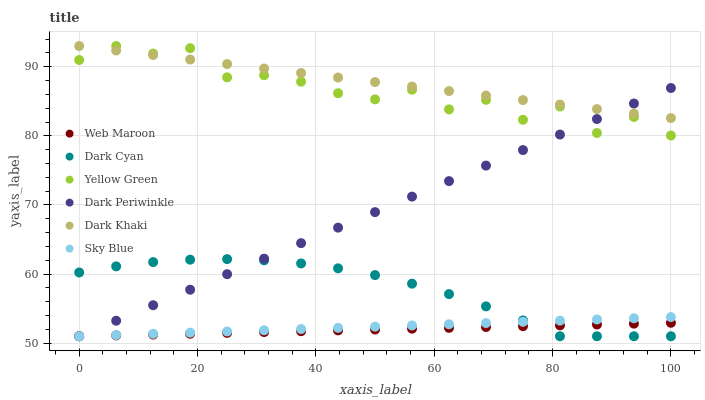Does Web Maroon have the minimum area under the curve?
Answer yes or no. Yes. Does Dark Khaki have the maximum area under the curve?
Answer yes or no. Yes. Does Dark Khaki have the minimum area under the curve?
Answer yes or no. No. Does Web Maroon have the maximum area under the curve?
Answer yes or no. No. Is Web Maroon the smoothest?
Answer yes or no. Yes. Is Yellow Green the roughest?
Answer yes or no. Yes. Is Dark Khaki the smoothest?
Answer yes or no. No. Is Dark Khaki the roughest?
Answer yes or no. No. Does Web Maroon have the lowest value?
Answer yes or no. Yes. Does Dark Khaki have the lowest value?
Answer yes or no. No. Does Dark Khaki have the highest value?
Answer yes or no. Yes. Does Web Maroon have the highest value?
Answer yes or no. No. Is Sky Blue less than Dark Khaki?
Answer yes or no. Yes. Is Yellow Green greater than Web Maroon?
Answer yes or no. Yes. Does Web Maroon intersect Dark Cyan?
Answer yes or no. Yes. Is Web Maroon less than Dark Cyan?
Answer yes or no. No. Is Web Maroon greater than Dark Cyan?
Answer yes or no. No. Does Sky Blue intersect Dark Khaki?
Answer yes or no. No. 